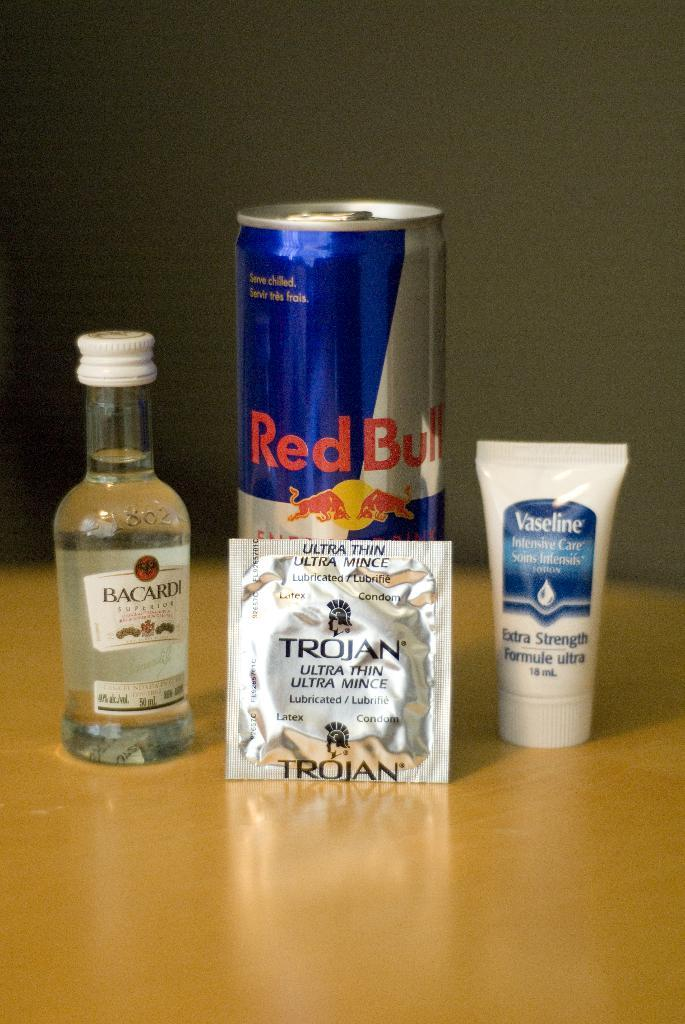<image>
Write a terse but informative summary of the picture. The can of red bull has a Trojan condom leaning on it, and is in between a travel sized bottle of Bacardi rum and a small tube of Vaseline. 